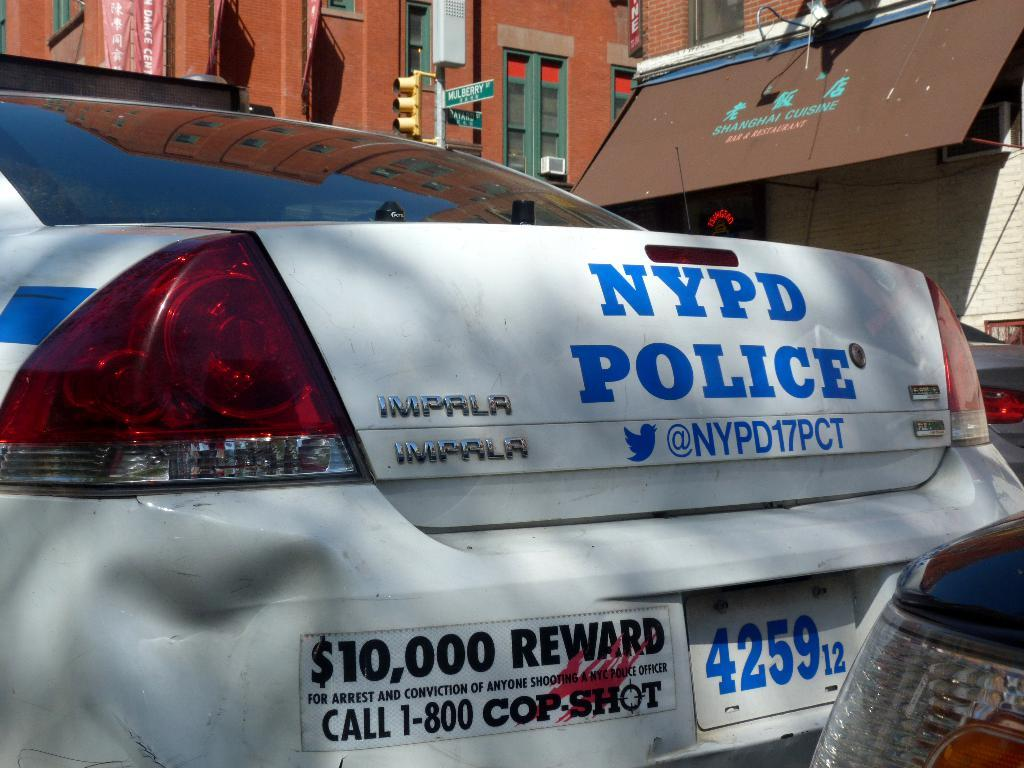What type of vehicles can be seen in the image? There are cars in the image. What type of structures are visible in the image? There are buildings with windows in the image. What road sign can be seen in the image? A street sign is present in the image. What device is used to control traffic in the image? The traffic signal is visible in the image. What type of sign is present in the image? A signboard is present in the image. What additional information is conveyed through text in the image? A banner with text is visible in the image. What type of rice is being cooked in the image? There is no rice present in the image; it features cars, buildings, street signs, traffic signals, signboards, and a banner with text. What is the duck's tendency in the image? There are no ducks present in the image. 